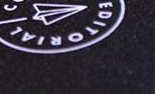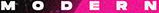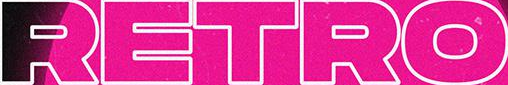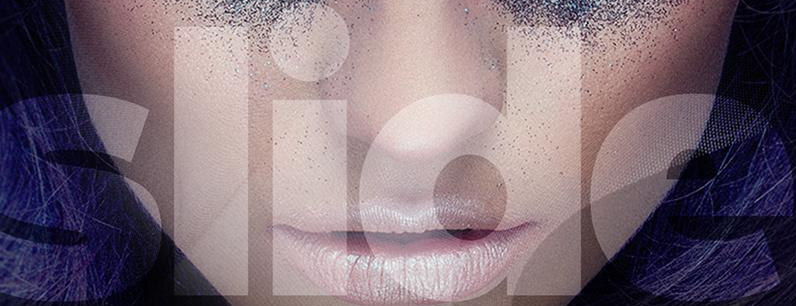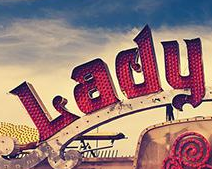What text appears in these images from left to right, separated by a semicolon? EDITORIAL; MODERN; RETRO; slide; Lady 